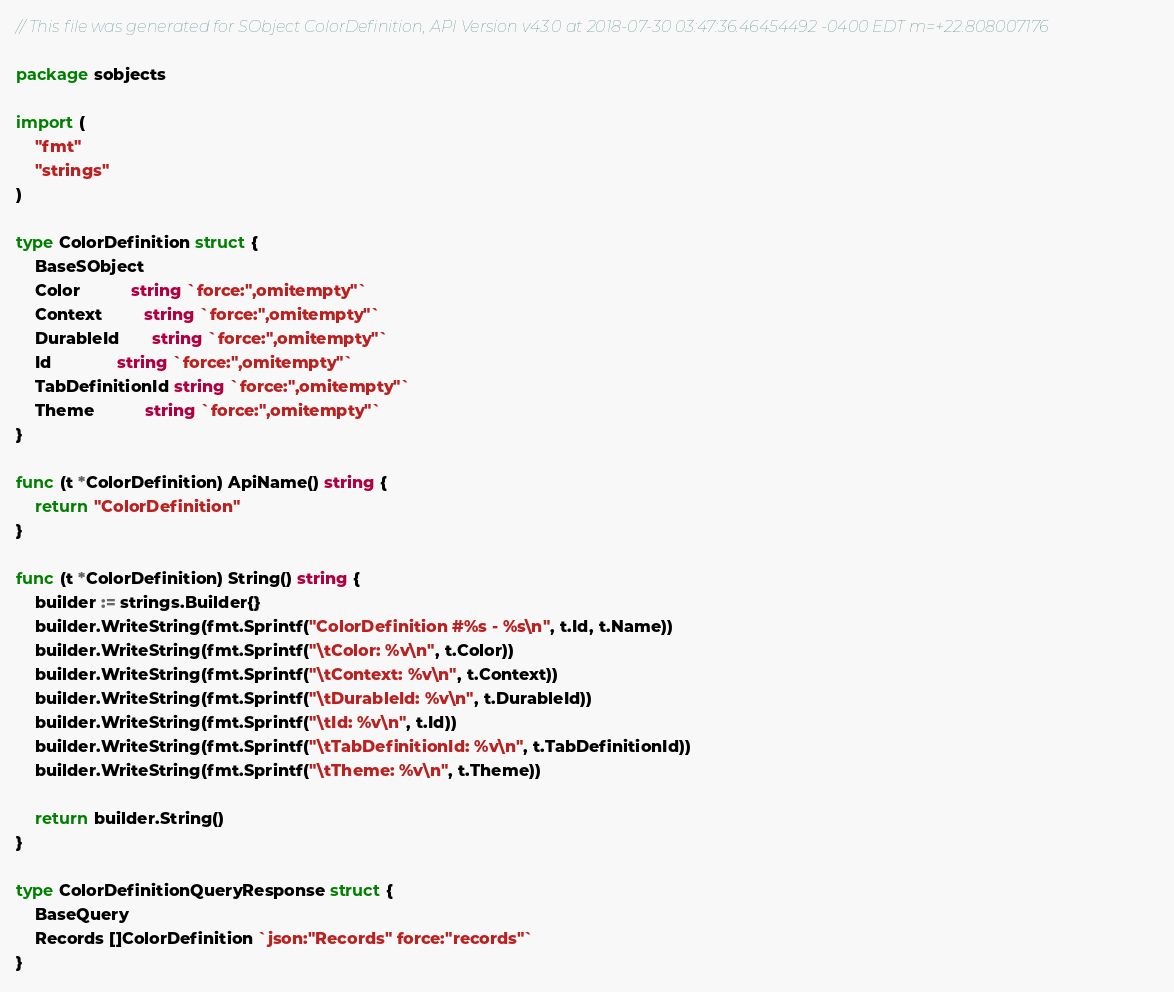<code> <loc_0><loc_0><loc_500><loc_500><_Go_>// This file was generated for SObject ColorDefinition, API Version v43.0 at 2018-07-30 03:47:36.46454492 -0400 EDT m=+22.808007176

package sobjects

import (
	"fmt"
	"strings"
)

type ColorDefinition struct {
	BaseSObject
	Color           string `force:",omitempty"`
	Context         string `force:",omitempty"`
	DurableId       string `force:",omitempty"`
	Id              string `force:",omitempty"`
	TabDefinitionId string `force:",omitempty"`
	Theme           string `force:",omitempty"`
}

func (t *ColorDefinition) ApiName() string {
	return "ColorDefinition"
}

func (t *ColorDefinition) String() string {
	builder := strings.Builder{}
	builder.WriteString(fmt.Sprintf("ColorDefinition #%s - %s\n", t.Id, t.Name))
	builder.WriteString(fmt.Sprintf("\tColor: %v\n", t.Color))
	builder.WriteString(fmt.Sprintf("\tContext: %v\n", t.Context))
	builder.WriteString(fmt.Sprintf("\tDurableId: %v\n", t.DurableId))
	builder.WriteString(fmt.Sprintf("\tId: %v\n", t.Id))
	builder.WriteString(fmt.Sprintf("\tTabDefinitionId: %v\n", t.TabDefinitionId))
	builder.WriteString(fmt.Sprintf("\tTheme: %v\n", t.Theme))

	return builder.String()
}

type ColorDefinitionQueryResponse struct {
	BaseQuery
	Records []ColorDefinition `json:"Records" force:"records"`
}
</code> 